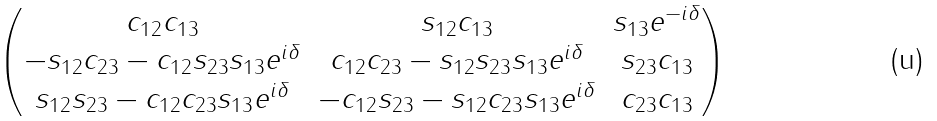Convert formula to latex. <formula><loc_0><loc_0><loc_500><loc_500>\begin{pmatrix} c _ { 1 2 } c _ { 1 3 } & s _ { 1 2 } c _ { 1 3 } & s _ { 1 3 } e ^ { - i \delta } \\ - s _ { 1 2 } c _ { 2 3 } - c _ { 1 2 } s _ { 2 3 } s _ { 1 3 } e ^ { i \delta } & c _ { 1 2 } c _ { 2 3 } - s _ { 1 2 } s _ { 2 3 } s _ { 1 3 } e ^ { i \delta } & s _ { 2 3 } c _ { 1 3 } \\ s _ { 1 2 } s _ { 2 3 } - c _ { 1 2 } c _ { 2 3 } s _ { 1 3 } e ^ { i \delta } & - c _ { 1 2 } s _ { 2 3 } - s _ { 1 2 } c _ { 2 3 } s _ { 1 3 } e ^ { i \delta } & c _ { 2 3 } c _ { 1 3 } \\ \end{pmatrix}</formula> 